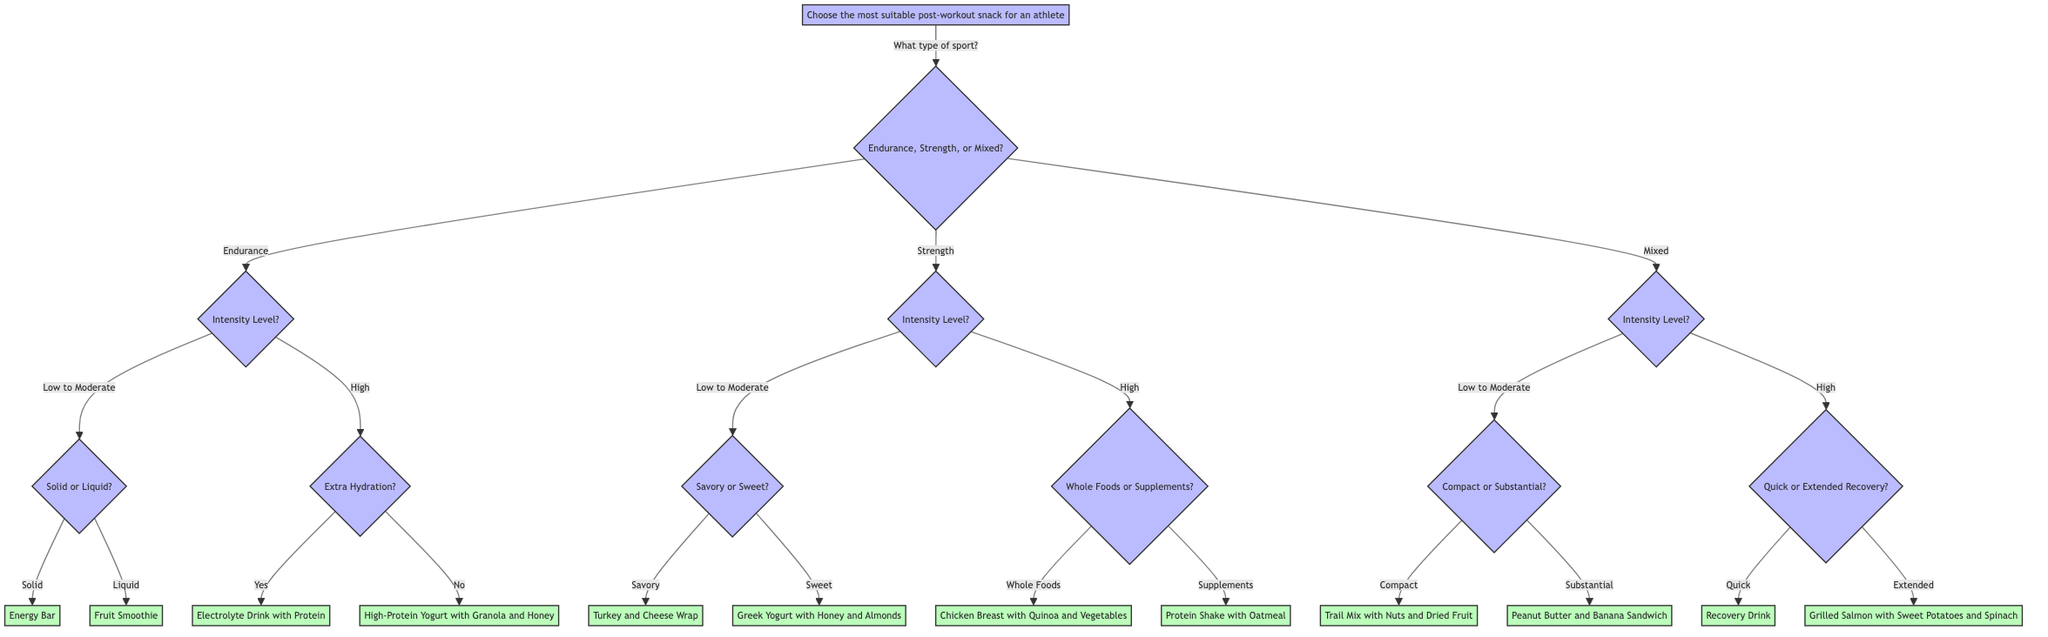What type of snacks are recommended for endurance athletes after a low to moderate intensity workout? According to the diagram, for endurance athletes, after a low to moderate intensity workout, the next decision is whether they prefer solid or liquid snacks. The choices led to Energy Bar for solid and Fruit Smoothie for liquid.
Answer: Energy Bar or Fruit Smoothie How many types of sports are represented in the diagram? The diagram contains three types of sports: Endurance, Strength, and Mixed. This is shown at the first decision node where the choices branch out into these three specific options.
Answer: Three What is the recommendation for strength athletes who prefer savory snacks after a low to moderate intensity workout? The flow indicates that for strength athletes at low to moderate intensity, if they prefer savory snacks, they are directed to Turkey and Cheese Wrap, which is noted under savory snacks in that branch.
Answer: Turkey and Cheese Wrap What are the differences in snack recommendations for high intensity mixed athletes needing quick recovery versus those needing extended recovery? For high intensity mixed athletes, if they need quick recovery, the recommendation is a Recovery Drink, while for extended recovery, it suggests Grilled Salmon with Sweet Potatoes and Spinach. This highlights the emphasis on immediate vs. prolonged recovery needs.
Answer: Recovery Drink or Grilled Salmon with Sweet Potatoes and Spinach What would an athlete do if they are participating in strength training and have low to moderate workout intensity? The diagram details that for strength training with low to moderate intensity, the athlete must choose between savory or sweet snacks. Hence, they will go through the next decision node asking for their preference to receive the right snack recommendation afterward.
Answer: Choose between savory or sweet snacks 